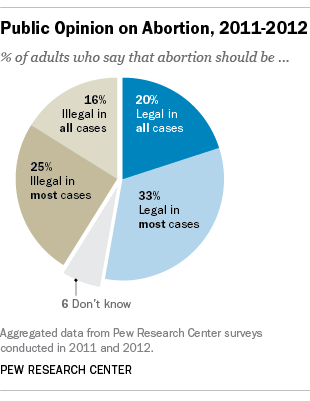Give some essential details in this illustration. According to a recent survey, approximately 33% of adults believe that abortion should be legal in most cases. The median of all segments is less than the sum of the two smallest segments. 